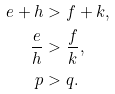<formula> <loc_0><loc_0><loc_500><loc_500>e + h & > f + k , \\ \frac { e } { h } & > \frac { f } { k } , \\ p & > q .</formula> 